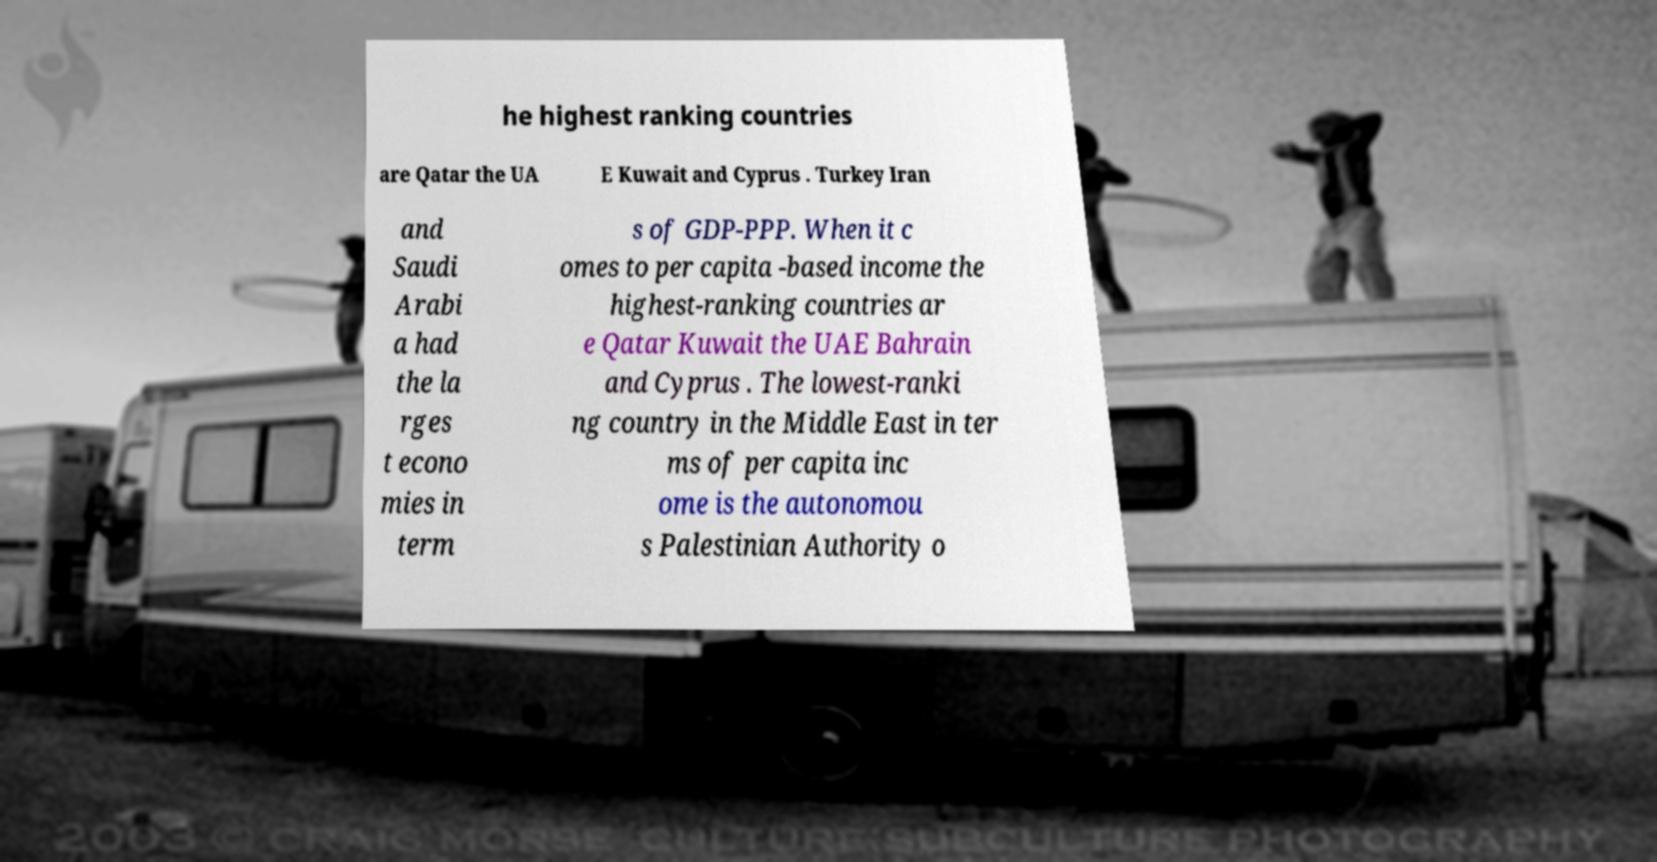Please read and relay the text visible in this image. What does it say? he highest ranking countries are Qatar the UA E Kuwait and Cyprus . Turkey Iran and Saudi Arabi a had the la rges t econo mies in term s of GDP-PPP. When it c omes to per capita -based income the highest-ranking countries ar e Qatar Kuwait the UAE Bahrain and Cyprus . The lowest-ranki ng country in the Middle East in ter ms of per capita inc ome is the autonomou s Palestinian Authority o 